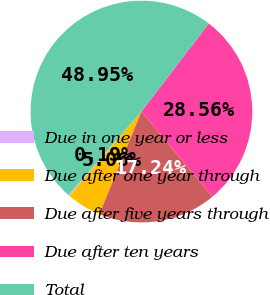<chart> <loc_0><loc_0><loc_500><loc_500><pie_chart><fcel>Due in one year or less<fcel>Due after one year through<fcel>Due after five years through<fcel>Due after ten years<fcel>Total<nl><fcel>0.19%<fcel>5.06%<fcel>17.24%<fcel>28.56%<fcel>48.95%<nl></chart> 